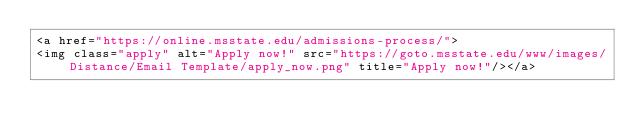Convert code to text. <code><loc_0><loc_0><loc_500><loc_500><_PHP_><a href="https://online.msstate.edu/admissions-process/">
<img class="apply" alt="Apply now!" src="https://goto.msstate.edu/www/images/Distance/Email Template/apply_now.png" title="Apply now!"/></a>
</code> 